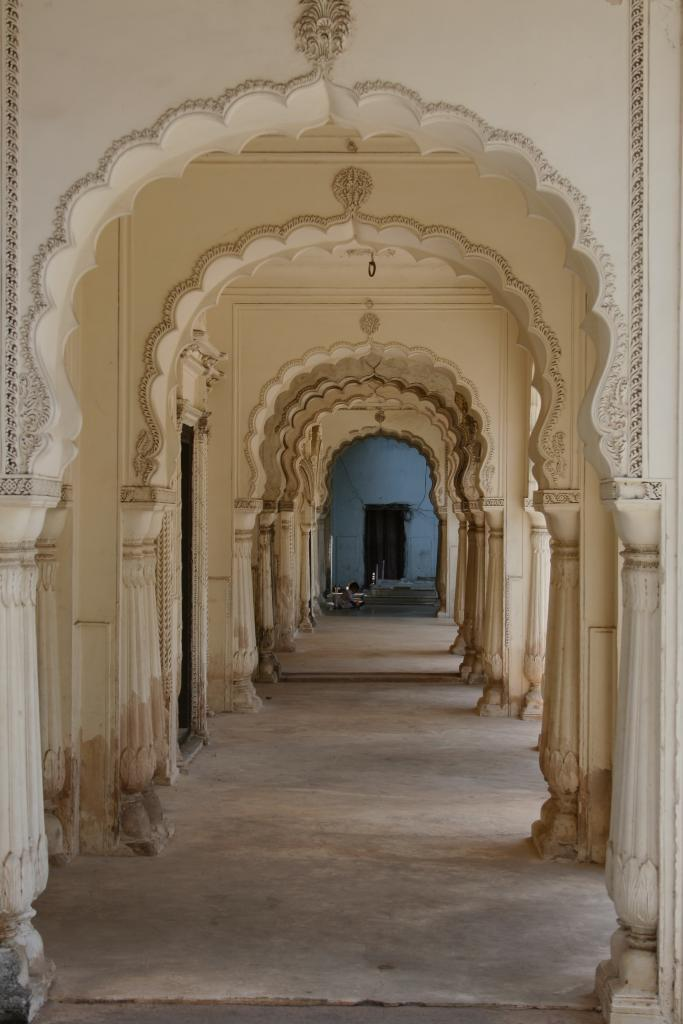What color are the walls in the image? The walls in the image are cream in color. What can be seen on the ground in the image? The ground is visible in the image. What architectural features are present in the image? There are pillars in the image. What is the color of the wall in the background of the image? The wall in the background of the image is blue in color. What is located on the wall in the background of the image? There is a door in the background of the image. What objects are on the ground in the background of the image? There are objects on the ground in the background of the image. How many people are in the crowd in the image? There is no crowd present in the image. What type of silk is draped over the pillars in the image? There is no silk present in the image. 